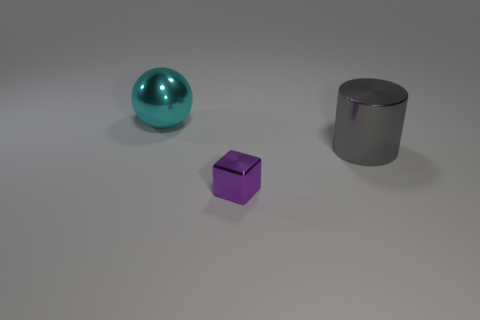What lighting conditions are apparent in this scene? The lighting in the scene seems to be diffused, casting soft shadows directly underneath the objects. This indicates an overhead light source, possibly in a studio setting. 